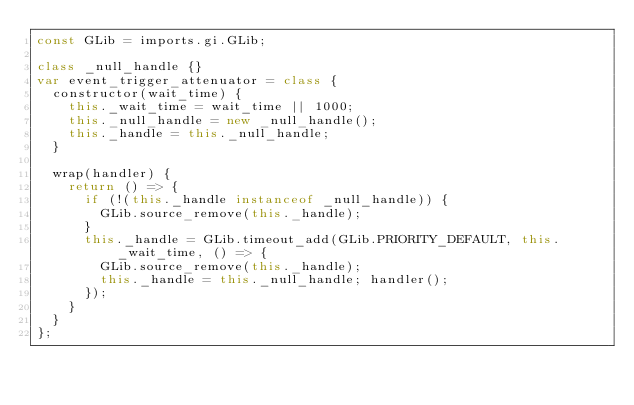Convert code to text. <code><loc_0><loc_0><loc_500><loc_500><_JavaScript_>const GLib = imports.gi.GLib;

class _null_handle {}
var event_trigger_attenuator = class {
  constructor(wait_time) {
    this._wait_time = wait_time || 1000;
    this._null_handle = new _null_handle();
    this._handle = this._null_handle;
  }

  wrap(handler) {
    return () => {
      if (!(this._handle instanceof _null_handle)) {
        GLib.source_remove(this._handle);
      }
      this._handle = GLib.timeout_add(GLib.PRIORITY_DEFAULT, this._wait_time, () => {
        GLib.source_remove(this._handle);
        this._handle = this._null_handle; handler();
      });
    }
  }
};
</code> 